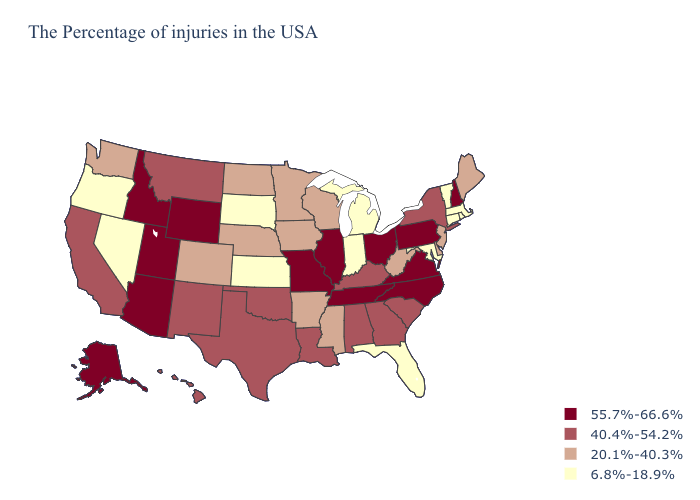Which states have the lowest value in the USA?
Short answer required. Massachusetts, Rhode Island, Vermont, Connecticut, Maryland, Florida, Michigan, Indiana, Kansas, South Dakota, Nevada, Oregon. What is the value of Texas?
Give a very brief answer. 40.4%-54.2%. Which states have the lowest value in the USA?
Keep it brief. Massachusetts, Rhode Island, Vermont, Connecticut, Maryland, Florida, Michigan, Indiana, Kansas, South Dakota, Nevada, Oregon. What is the lowest value in the South?
Quick response, please. 6.8%-18.9%. Does the first symbol in the legend represent the smallest category?
Concise answer only. No. Does Indiana have the highest value in the MidWest?
Concise answer only. No. Name the states that have a value in the range 55.7%-66.6%?
Concise answer only. New Hampshire, Pennsylvania, Virginia, North Carolina, Ohio, Tennessee, Illinois, Missouri, Wyoming, Utah, Arizona, Idaho, Alaska. Name the states that have a value in the range 55.7%-66.6%?
Write a very short answer. New Hampshire, Pennsylvania, Virginia, North Carolina, Ohio, Tennessee, Illinois, Missouri, Wyoming, Utah, Arizona, Idaho, Alaska. Does Wisconsin have the lowest value in the USA?
Quick response, please. No. Among the states that border Oregon , does Nevada have the lowest value?
Be succinct. Yes. What is the highest value in the USA?
Give a very brief answer. 55.7%-66.6%. Does the first symbol in the legend represent the smallest category?
Short answer required. No. What is the value of New Mexico?
Answer briefly. 40.4%-54.2%. Name the states that have a value in the range 40.4%-54.2%?
Keep it brief. New York, South Carolina, Georgia, Kentucky, Alabama, Louisiana, Oklahoma, Texas, New Mexico, Montana, California, Hawaii. What is the value of South Carolina?
Concise answer only. 40.4%-54.2%. 